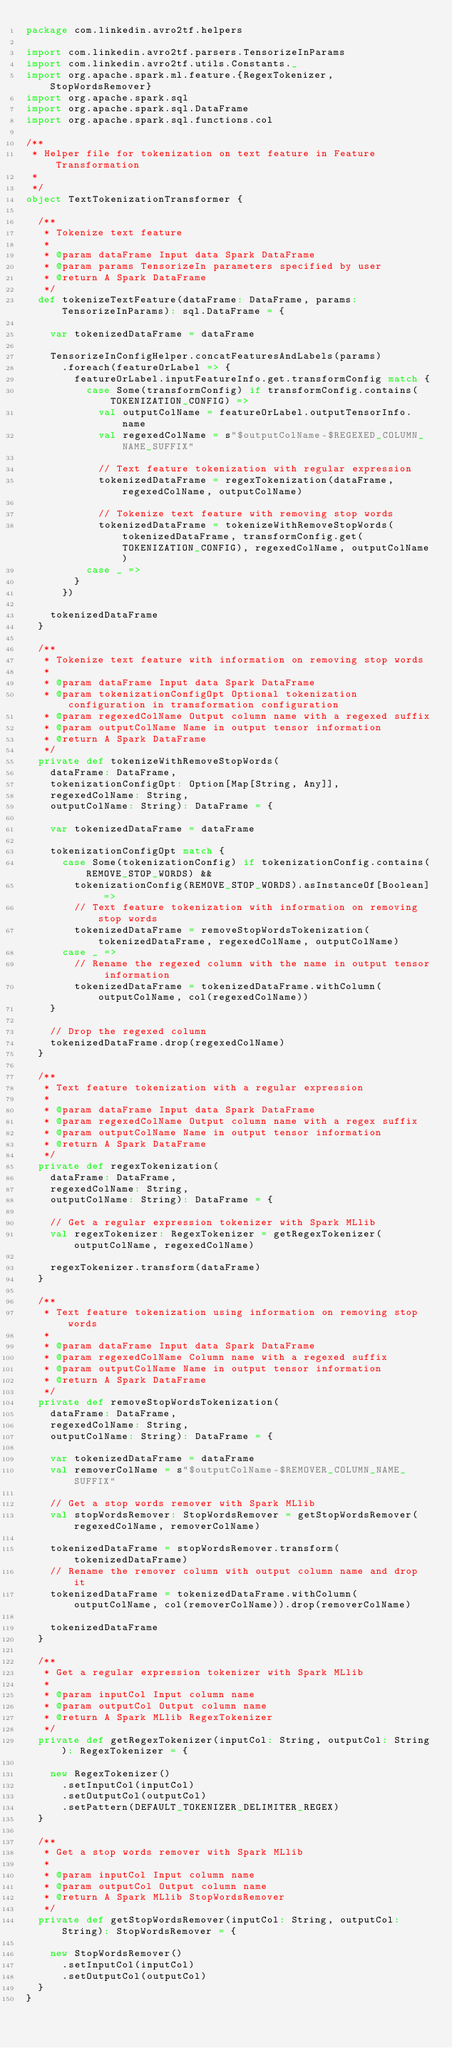<code> <loc_0><loc_0><loc_500><loc_500><_Scala_>package com.linkedin.avro2tf.helpers

import com.linkedin.avro2tf.parsers.TensorizeInParams
import com.linkedin.avro2tf.utils.Constants._
import org.apache.spark.ml.feature.{RegexTokenizer, StopWordsRemover}
import org.apache.spark.sql
import org.apache.spark.sql.DataFrame
import org.apache.spark.sql.functions.col

/**
 * Helper file for tokenization on text feature in Feature Transformation
 *
 */
object TextTokenizationTransformer {

  /**
   * Tokenize text feature
   *
   * @param dataFrame Input data Spark DataFrame
   * @param params TensorizeIn parameters specified by user
   * @return A Spark DataFrame
   */
  def tokenizeTextFeature(dataFrame: DataFrame, params: TensorizeInParams): sql.DataFrame = {

    var tokenizedDataFrame = dataFrame

    TensorizeInConfigHelper.concatFeaturesAndLabels(params)
      .foreach(featureOrLabel => {
        featureOrLabel.inputFeatureInfo.get.transformConfig match {
          case Some(transformConfig) if transformConfig.contains(TOKENIZATION_CONFIG) =>
            val outputColName = featureOrLabel.outputTensorInfo.name
            val regexedColName = s"$outputColName-$REGEXED_COLUMN_NAME_SUFFIX"

            // Text feature tokenization with regular expression
            tokenizedDataFrame = regexTokenization(dataFrame, regexedColName, outputColName)

            // Tokenize text feature with removing stop words
            tokenizedDataFrame = tokenizeWithRemoveStopWords(tokenizedDataFrame, transformConfig.get(TOKENIZATION_CONFIG), regexedColName, outputColName)
          case _ =>
        }
      })

    tokenizedDataFrame
  }

  /**
   * Tokenize text feature with information on removing stop words
   *
   * @param dataFrame Input data Spark DataFrame
   * @param tokenizationConfigOpt Optional tokenization configuration in transformation configuration
   * @param regexedColName Output column name with a regexed suffix
   * @param outputColName Name in output tensor information
   * @return A Spark DataFrame
   */
  private def tokenizeWithRemoveStopWords(
    dataFrame: DataFrame,
    tokenizationConfigOpt: Option[Map[String, Any]],
    regexedColName: String,
    outputColName: String): DataFrame = {

    var tokenizedDataFrame = dataFrame

    tokenizationConfigOpt match {
      case Some(tokenizationConfig) if tokenizationConfig.contains(REMOVE_STOP_WORDS) &&
        tokenizationConfig(REMOVE_STOP_WORDS).asInstanceOf[Boolean] =>
        // Text feature tokenization with information on removing stop words
        tokenizedDataFrame = removeStopWordsTokenization(tokenizedDataFrame, regexedColName, outputColName)
      case _ =>
        // Rename the regexed column with the name in output tensor information
        tokenizedDataFrame = tokenizedDataFrame.withColumn(outputColName, col(regexedColName))
    }

    // Drop the regexed column
    tokenizedDataFrame.drop(regexedColName)
  }

  /**
   * Text feature tokenization with a regular expression
   *
   * @param dataFrame Input data Spark DataFrame
   * @param regexedColName Output column name with a regex suffix
   * @param outputColName Name in output tensor information
   * @return A Spark DataFrame
   */
  private def regexTokenization(
    dataFrame: DataFrame,
    regexedColName: String,
    outputColName: String): DataFrame = {

    // Get a regular expression tokenizer with Spark MLlib
    val regexTokenizer: RegexTokenizer = getRegexTokenizer(outputColName, regexedColName)

    regexTokenizer.transform(dataFrame)
  }

  /**
   * Text feature tokenization using information on removing stop words
   *
   * @param dataFrame Input data Spark DataFrame
   * @param regexedColName Column name with a regexed suffix
   * @param outputColName Name in output tensor information
   * @return A Spark DataFrame
   */
  private def removeStopWordsTokenization(
    dataFrame: DataFrame,
    regexedColName: String,
    outputColName: String): DataFrame = {

    var tokenizedDataFrame = dataFrame
    val removerColName = s"$outputColName-$REMOVER_COLUMN_NAME_SUFFIX"

    // Get a stop words remover with Spark MLlib
    val stopWordsRemover: StopWordsRemover = getStopWordsRemover(regexedColName, removerColName)

    tokenizedDataFrame = stopWordsRemover.transform(tokenizedDataFrame)
    // Rename the remover column with output column name and drop it
    tokenizedDataFrame = tokenizedDataFrame.withColumn(outputColName, col(removerColName)).drop(removerColName)

    tokenizedDataFrame
  }

  /**
   * Get a regular expression tokenizer with Spark MLlib
   *
   * @param inputCol Input column name
   * @param outputCol Output column name
   * @return A Spark MLlib RegexTokenizer
   */
  private def getRegexTokenizer(inputCol: String, outputCol: String): RegexTokenizer = {

    new RegexTokenizer()
      .setInputCol(inputCol)
      .setOutputCol(outputCol)
      .setPattern(DEFAULT_TOKENIZER_DELIMITER_REGEX)
  }

  /**
   * Get a stop words remover with Spark MLlib
   *
   * @param inputCol Input column name
   * @param outputCol Output column name
   * @return A Spark MLlib StopWordsRemover
   */
  private def getStopWordsRemover(inputCol: String, outputCol: String): StopWordsRemover = {

    new StopWordsRemover()
      .setInputCol(inputCol)
      .setOutputCol(outputCol)
  }
}</code> 